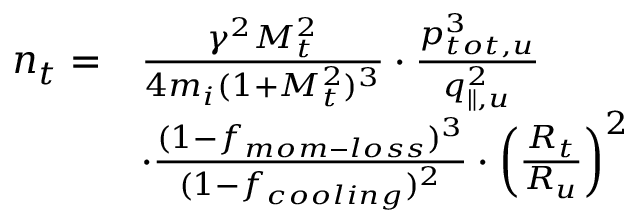<formula> <loc_0><loc_0><loc_500><loc_500>\begin{array} { r l } { n _ { t } = } & { \frac { \gamma ^ { 2 } M _ { t } ^ { 2 } } { 4 m _ { i } ( 1 + M _ { t } ^ { 2 } ) ^ { 3 } } \cdot \frac { p _ { t o t , u } ^ { 3 } } { q _ { \| , u } ^ { 2 } } } \\ & { \cdot \frac { ( 1 - f _ { m o m - l o s s } ) ^ { 3 } } { ( 1 - f _ { c o o l i n g } ) ^ { 2 } } \cdot \left ( \frac { R _ { t } } { R _ { u } } \right ) ^ { 2 } } \end{array}</formula> 